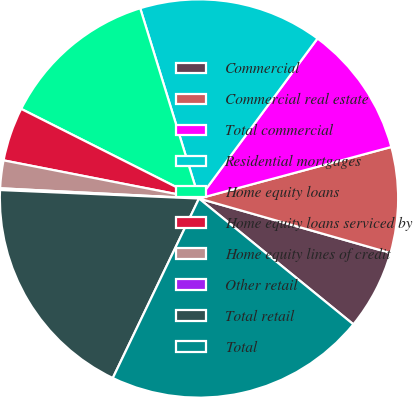Convert chart to OTSL. <chart><loc_0><loc_0><loc_500><loc_500><pie_chart><fcel>Commercial<fcel>Commercial real estate<fcel>Total commercial<fcel>Residential mortgages<fcel>Home equity loans<fcel>Home equity loans serviced by<fcel>Home equity lines of credit<fcel>Other retail<fcel>Total retail<fcel>Total<nl><fcel>6.47%<fcel>8.58%<fcel>10.69%<fcel>14.91%<fcel>12.8%<fcel>4.36%<fcel>2.25%<fcel>0.14%<fcel>18.55%<fcel>21.24%<nl></chart> 